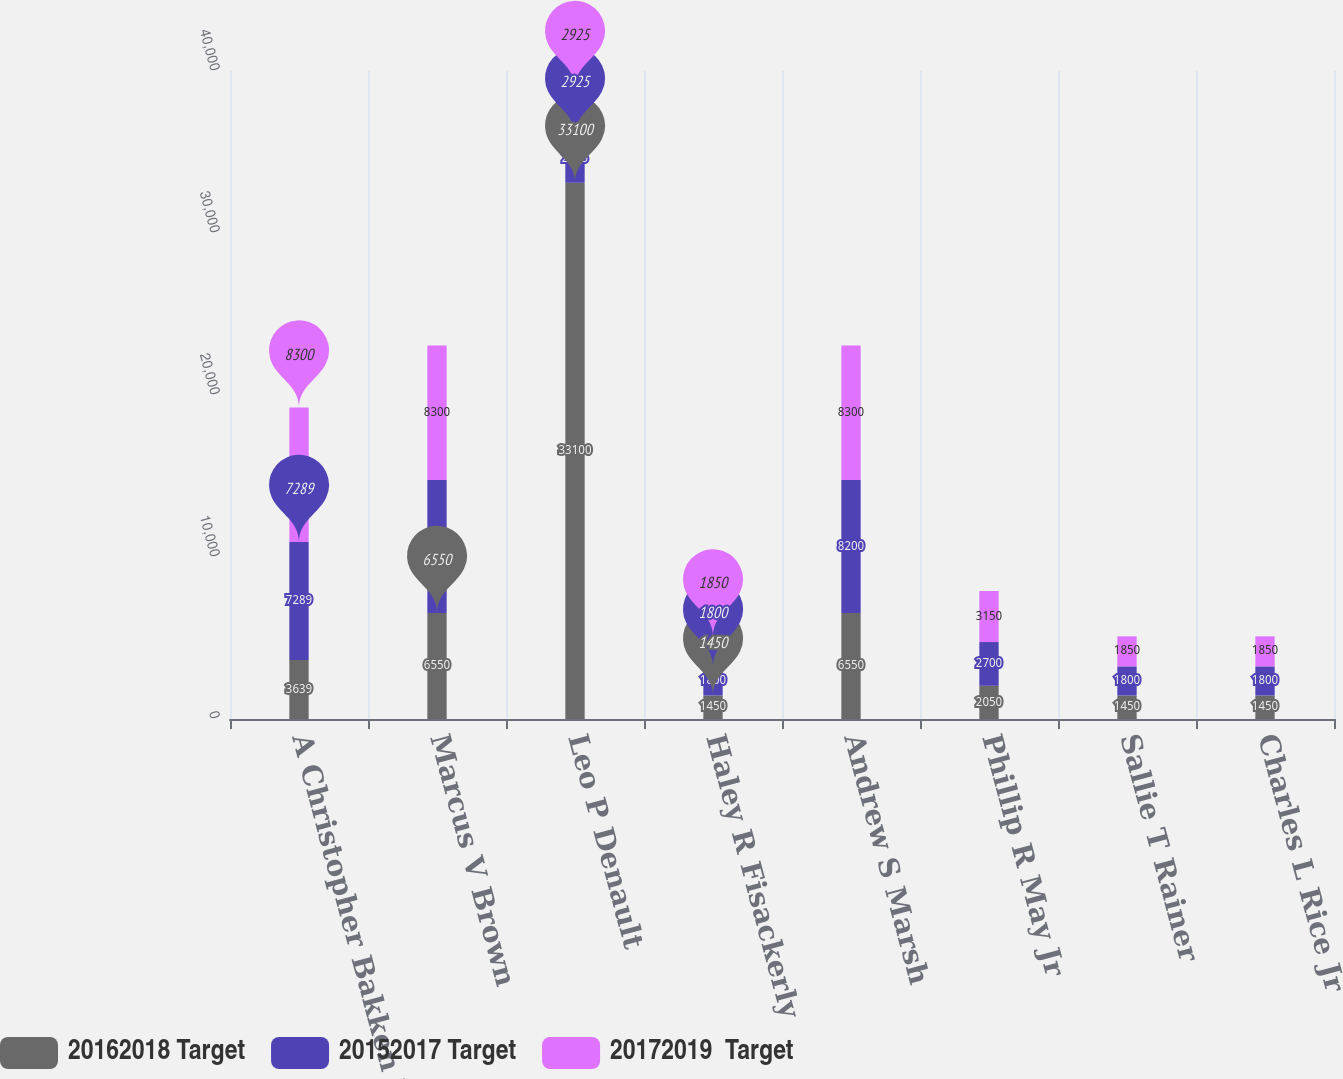Convert chart. <chart><loc_0><loc_0><loc_500><loc_500><stacked_bar_chart><ecel><fcel>A Christopher Bakken III (1)<fcel>Marcus V Brown<fcel>Leo P Denault<fcel>Haley R Fisackerly<fcel>Andrew S Marsh<fcel>Phillip R May Jr<fcel>Sallie T Rainer<fcel>Charles L Rice Jr<nl><fcel>20162018 Target<fcel>3639<fcel>6550<fcel>33100<fcel>1450<fcel>6550<fcel>2050<fcel>1450<fcel>1450<nl><fcel>20152017 Target<fcel>7289<fcel>8200<fcel>2925<fcel>1800<fcel>8200<fcel>2700<fcel>1800<fcel>1800<nl><fcel>20172019  Target<fcel>8300<fcel>8300<fcel>2925<fcel>1850<fcel>8300<fcel>3150<fcel>1850<fcel>1850<nl></chart> 